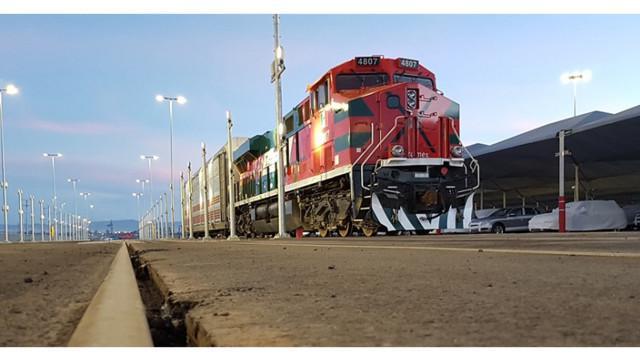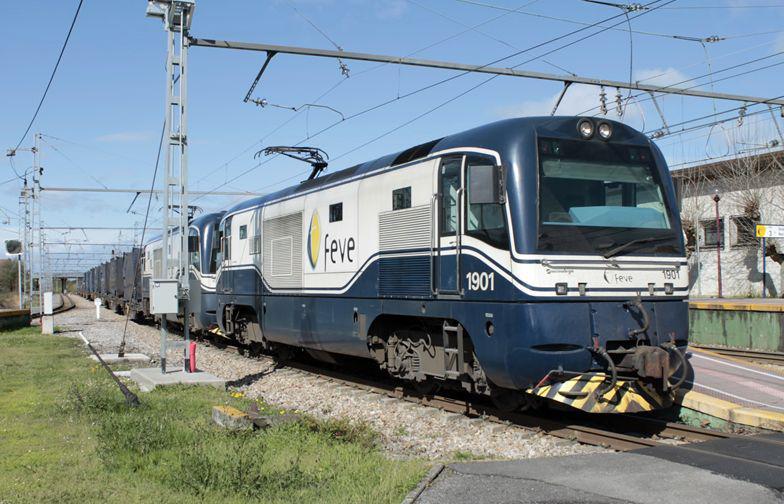The first image is the image on the left, the second image is the image on the right. For the images displayed, is the sentence "on the right side a single care is heading to the left" factually correct? Answer yes or no. No. The first image is the image on the left, the second image is the image on the right. Considering the images on both sides, is "In the right image, the train doesn't appear to be hauling anything." valid? Answer yes or no. No. 